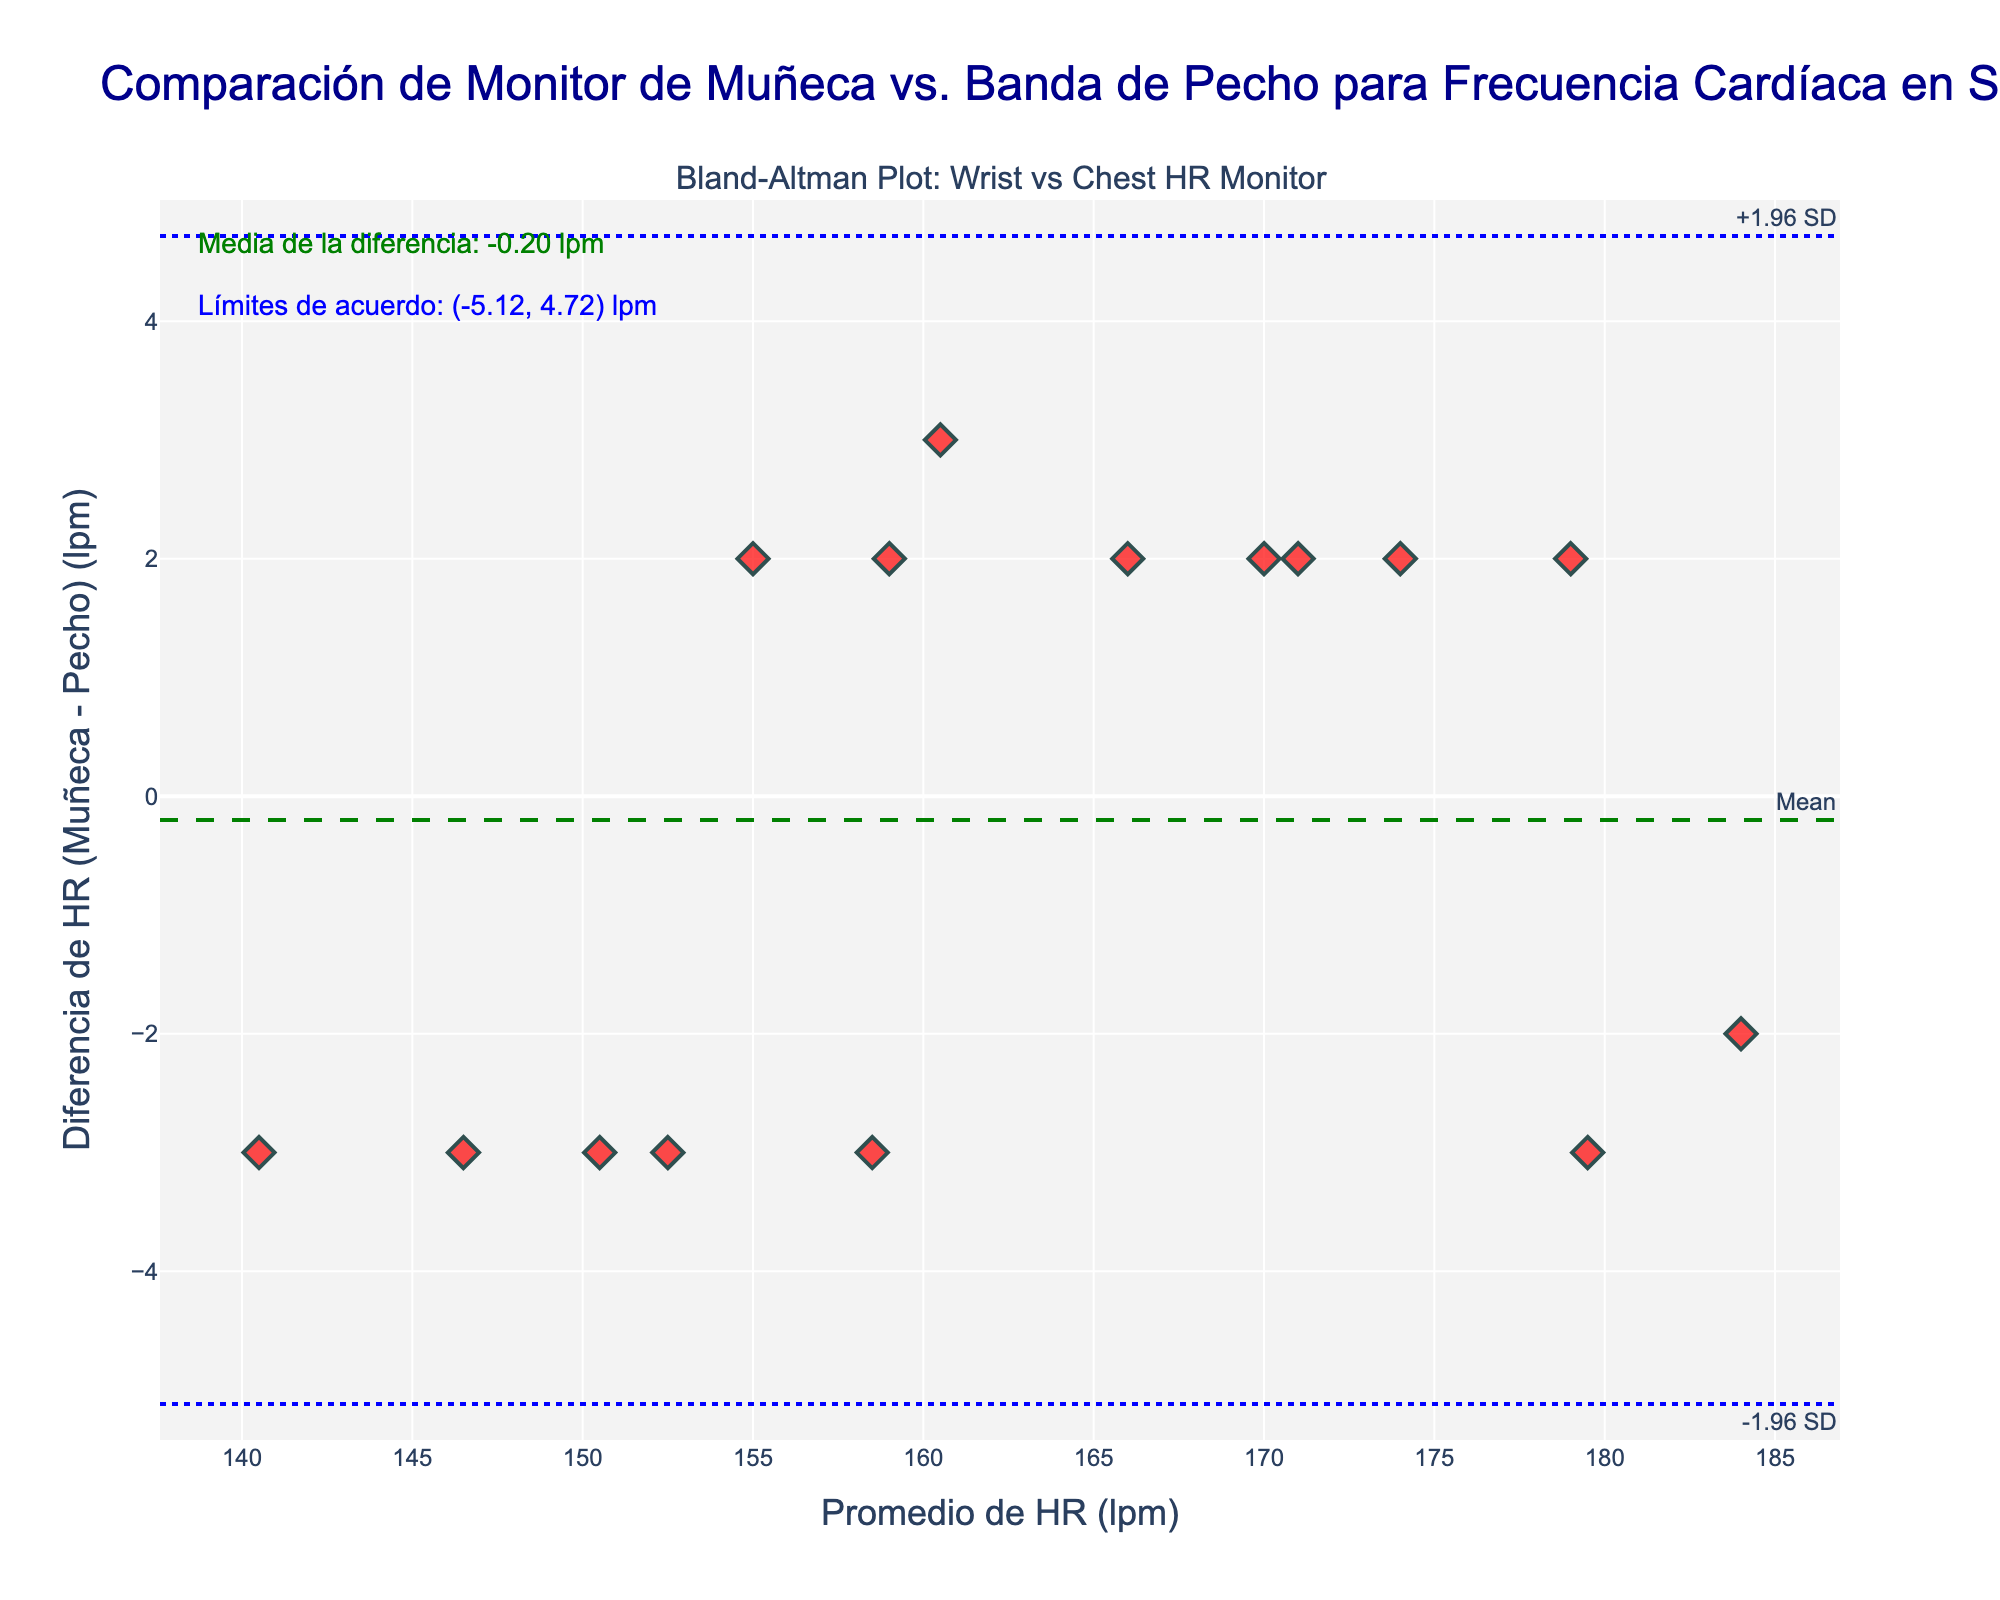What is the title of the plot? The title of the plot is located at the top and is displayed in a large font. Reading the title reveals: "Comparación de Monitor de Muñeca vs. Banda de Pecho para Frecuencia Cardíaca en Squash"
Answer: Comparación de Monitor de Muñeca vs. Banda de Pecho para Frecuencia Cardíaca en Squash What are the x-axis and y-axis labels? The x-axis label reads "Promedio de HR (lpm)" and the y-axis label reads "Diferencia de HR (Muñeca - Pecho) (lpm)", which are found next to their respective axes.
Answer: Promedio de HR (lpm); Diferencia de HR (Muñeca - Pecho) (lpm) How many data points are there in the plot? Each data point is represented by a diamond marker. Counting these markers reveals there are 15 data points.
Answer: 15 What is the mean difference of the heart rate measurements between wrist and chest monitors? The mean difference is shown as an annotation and indicated by a dashed green line. Reading the annotation text reveals it is "Media de la diferencia: 0.00 lpm".
Answer: 0.00 lpm What do the blue dotted lines represent? The blue dotted lines are labeled as "+1.96 SD" and "-1.96 SD". They represent the limits of agreement, which are calculated as mean difference ± 1.96 times the standard deviation of the differences.
Answer: Limits of agreement What is the range of the limits of agreement? The limits of agreement are stated in an annotation. Reading the annotation reveals they are "(lower = -4.91, upper = 4.91) lpm".
Answer: (-4.91, 4.91) lpm How does the mean difference compare to the limits of agreement? The mean difference (0.00 lpm) is centrally placed between the limits of agreement (-4.91, 4.91 lpm). This means the average discrepancy is zero while the extreme differences are ±4.91 lpm.
Answer: Centrally placed Which participant has the largest absolute difference in heart rate measurements between wrist and chest monitors? The participant with the largest absolute difference has the highest vertical displacement from the mean line. Observing the plot, "Roberto Pezzota" with a difference of -2 (183 - 185) has the largest disparity.
Answer: Roberto Pezzota Are most of the data points within the limits of agreement? Observing the placement of the markers, most data points fall between the blue dotted lines which represent the limits of agreement. Only a few data points are outside these lines.
Answer: Yes Do any data points lie exactly on the mean difference line? The dashed green line represents the mean difference. Looking at the plot, several markers lie directly on this line, indicating cases where wrist and chest measurement differences are zero.
Answer: Yes 